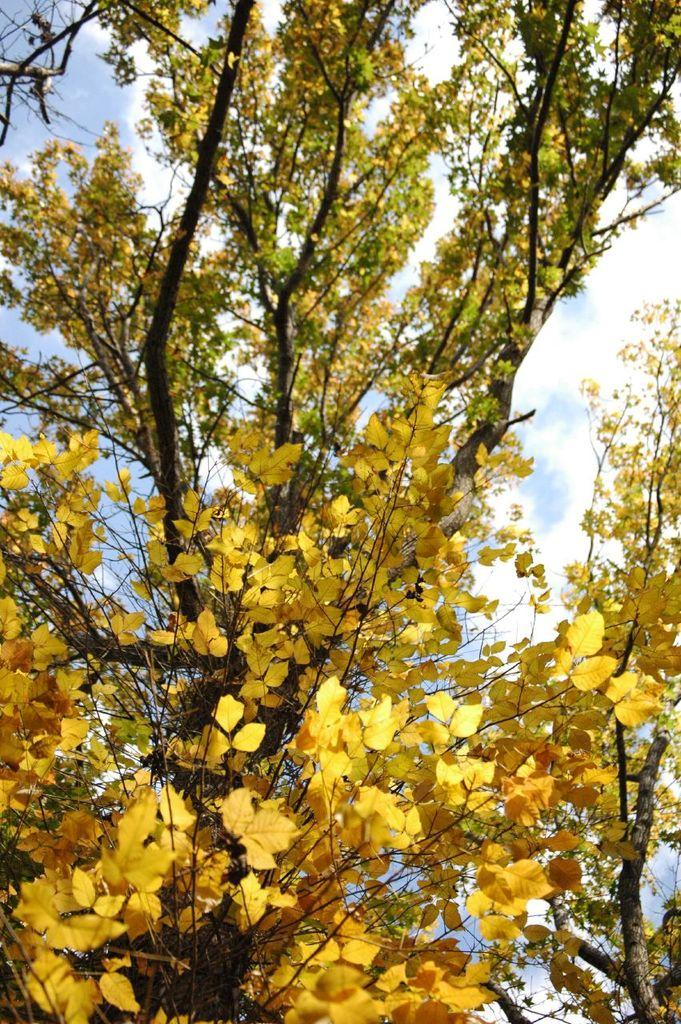What is the main subject in the center of the image? There is a tree in the center of the image. What can be seen in the background of the image? Sky and clouds are visible in the background of the image. How many people are wearing a shirt with the same color as the tree in the image? There are no people present in the image, so it is not possible to determine how many people might be wearing a shirt with the same color as the tree. 